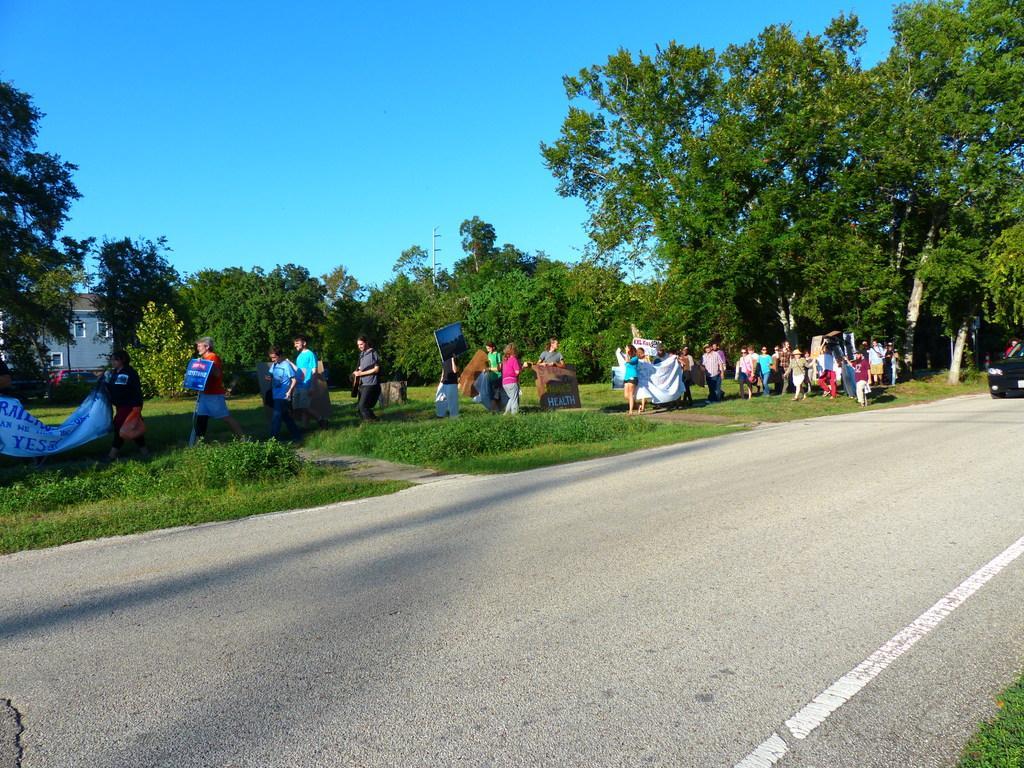In one or two sentences, can you explain what this image depicts? In this picture we can see a vehicle on the road, building with windows, trees and a group of people walking on grass and holding banners with their hands and in the background we can see the sky. 